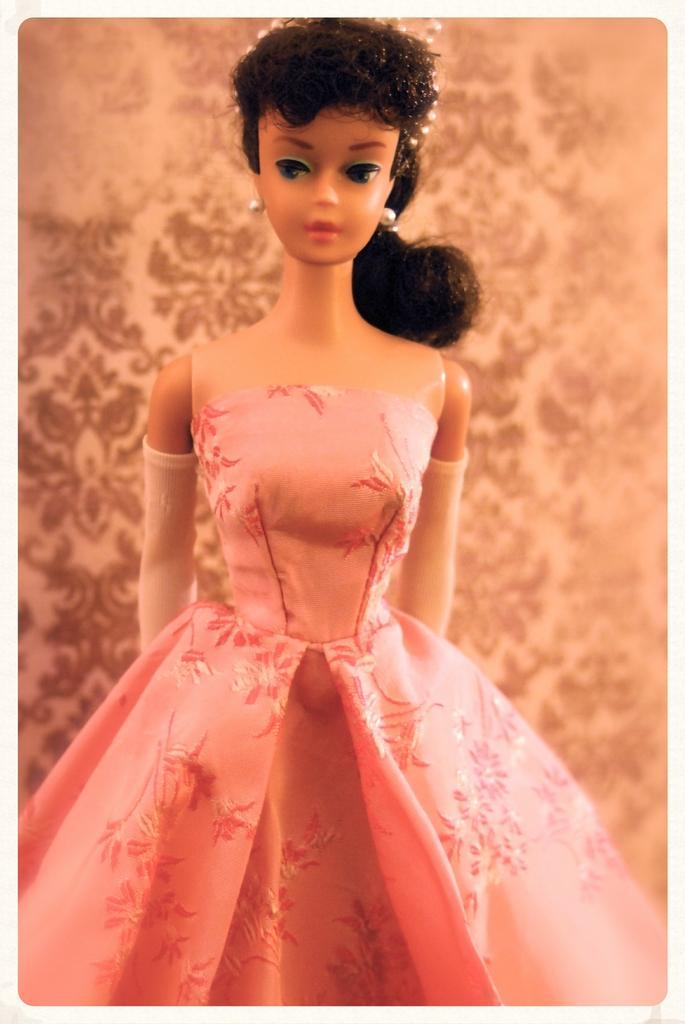Please provide a concise description of this image. In the center of the image we can see a doll with a different costume. In the background there is a wall with some design on it. 